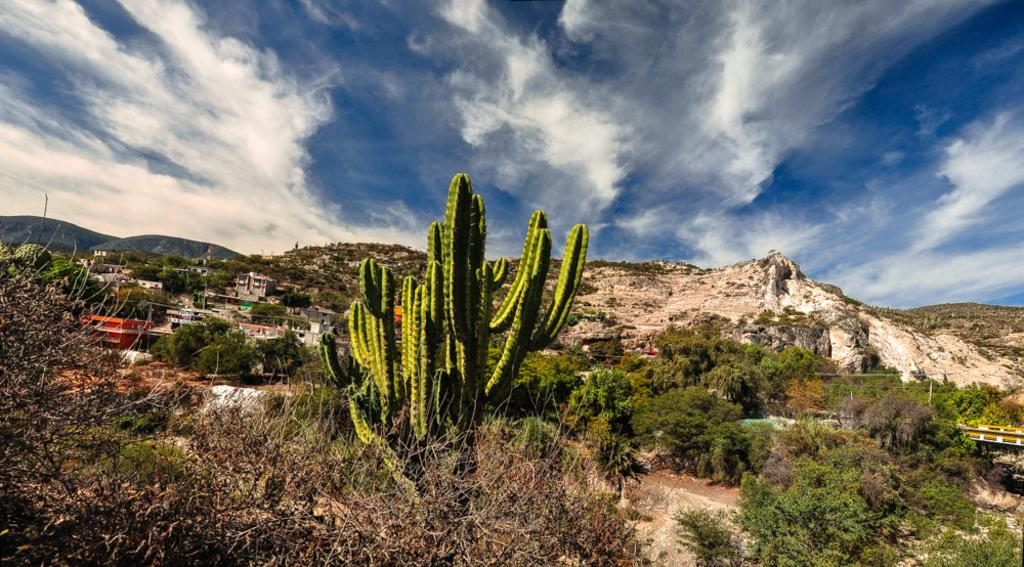What type of vegetation is present in the image? There are plants and trees in the image. What color are the plants and trees? The plants and trees are green. What can be seen in the background of the image? There are buildings and mountains in the background of the image. What is the color of the sky in the image? The sky is blue and white. What type of joke is being told by the kettle in the image? There is no kettle present in the image, so no joke can be attributed to it. 